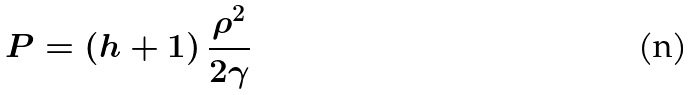<formula> <loc_0><loc_0><loc_500><loc_500>P = \left ( h + 1 \right ) \frac { \rho ^ { 2 } } { 2 \gamma }</formula> 